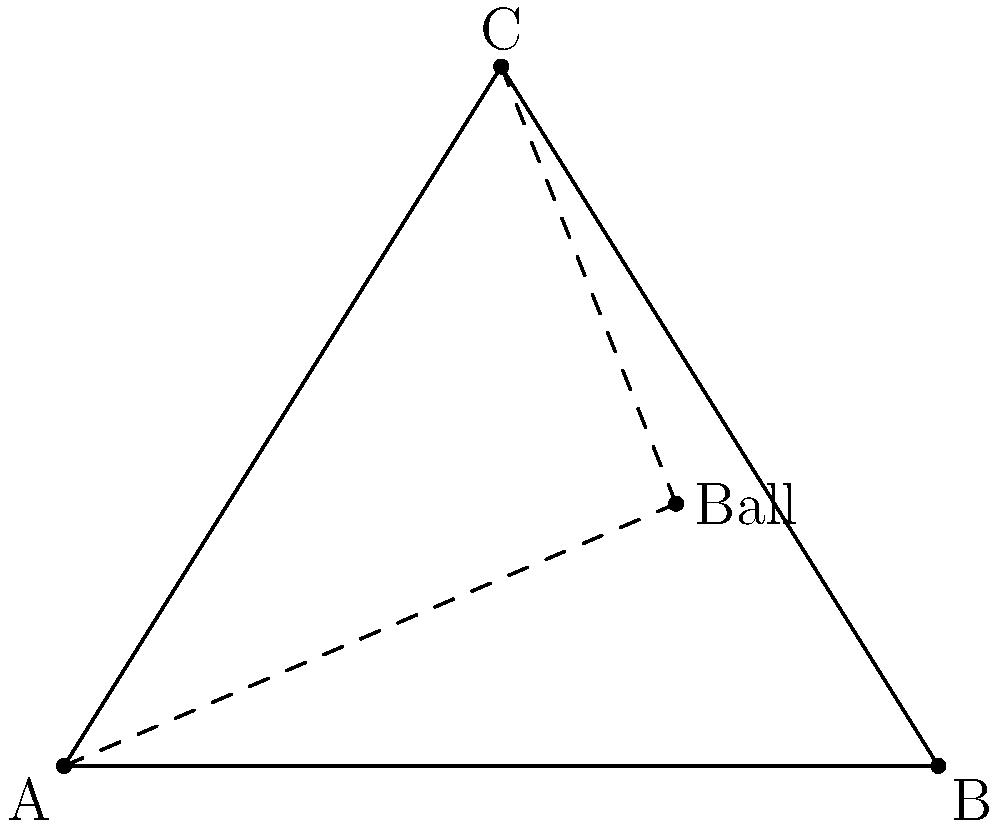In a cricket field, a ball is hit to a position 7 meters from the left boundary and 3 meters from the bottom boundary. Two fielders, one at point A (0,0) and another at point C (5,8), want to catch the ball. Who should go for the catch to minimize the distance traveled? Calculate the difference in distances between the two fielders to the ball. Let's solve this step-by-step:

1) First, we need to calculate the distance from each fielder to the ball using the distance formula: 
   $d = \sqrt{(x_2-x_1)^2 + (y_2-y_1)^2}$

2) For fielder A (0,0) to the ball (7,3):
   $d_A = \sqrt{(7-0)^2 + (3-0)^2} = \sqrt{49 + 9} = \sqrt{58}$ meters

3) For fielder C (5,8) to the ball (7,3):
   $d_C = \sqrt{(7-5)^2 + (3-8)^2} = \sqrt{4 + 25} = \sqrt{29}$ meters

4) To find the difference, we subtract:
   $d_A - d_C = \sqrt{58} - \sqrt{29}$ meters

5) To simplify:
   $\sqrt{58} - \sqrt{29} = \sqrt{58} - \sqrt{29} \approx 2.62$ meters

Therefore, fielder C should go for the catch as they are closer to the ball. The difference in distance is approximately 2.62 meters.
Answer: Fielder C; $\sqrt{58} - \sqrt{29} \approx 2.62$ meters 